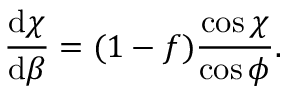<formula> <loc_0><loc_0><loc_500><loc_500>\frac { \mathrm d \chi } { \mathrm d \beta } = ( 1 - f ) \frac { \cos \chi } { \cos \phi } .</formula> 